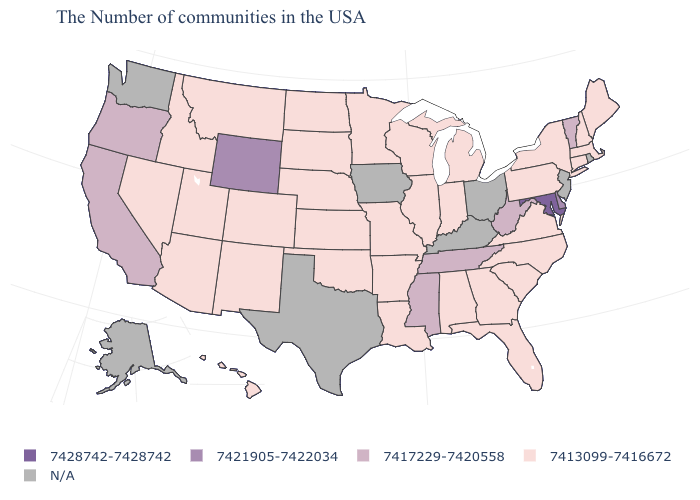Does Utah have the highest value in the USA?
Be succinct. No. What is the value of Wisconsin?
Answer briefly. 7413099-7416672. Which states have the highest value in the USA?
Write a very short answer. Maryland. What is the value of Colorado?
Answer briefly. 7413099-7416672. What is the value of Washington?
Quick response, please. N/A. What is the lowest value in the South?
Write a very short answer. 7413099-7416672. Name the states that have a value in the range 7421905-7422034?
Quick response, please. Delaware, Wyoming. Name the states that have a value in the range 7421905-7422034?
Short answer required. Delaware, Wyoming. Name the states that have a value in the range 7428742-7428742?
Answer briefly. Maryland. What is the value of New Hampshire?
Be succinct. 7413099-7416672. Name the states that have a value in the range 7413099-7416672?
Concise answer only. Maine, Massachusetts, New Hampshire, Connecticut, New York, Pennsylvania, Virginia, North Carolina, South Carolina, Florida, Georgia, Michigan, Indiana, Alabama, Wisconsin, Illinois, Louisiana, Missouri, Arkansas, Minnesota, Kansas, Nebraska, Oklahoma, South Dakota, North Dakota, Colorado, New Mexico, Utah, Montana, Arizona, Idaho, Nevada, Hawaii. What is the value of Georgia?
Short answer required. 7413099-7416672. Does the first symbol in the legend represent the smallest category?
Write a very short answer. No. Among the states that border Mississippi , which have the highest value?
Concise answer only. Tennessee. 